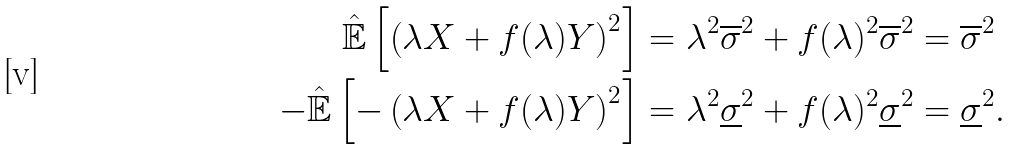<formula> <loc_0><loc_0><loc_500><loc_500>\hat { \mathbb { E } } \left [ \left ( \lambda X + f ( \lambda ) Y \right ) ^ { 2 } \right ] & = \lambda ^ { 2 } \overline { \sigma } ^ { 2 } + f ( \lambda ) ^ { 2 } \overline { \sigma } ^ { 2 } = \overline { \sigma } ^ { 2 } \\ - \hat { \mathbb { E } } \left [ - \left ( \lambda X + f ( \lambda ) Y \right ) ^ { 2 } \right ] & = \lambda ^ { 2 } \underline { \sigma } ^ { 2 } + f ( \lambda ) ^ { 2 } \underline { \sigma } ^ { 2 } = \underline { \sigma } ^ { 2 } .</formula> 